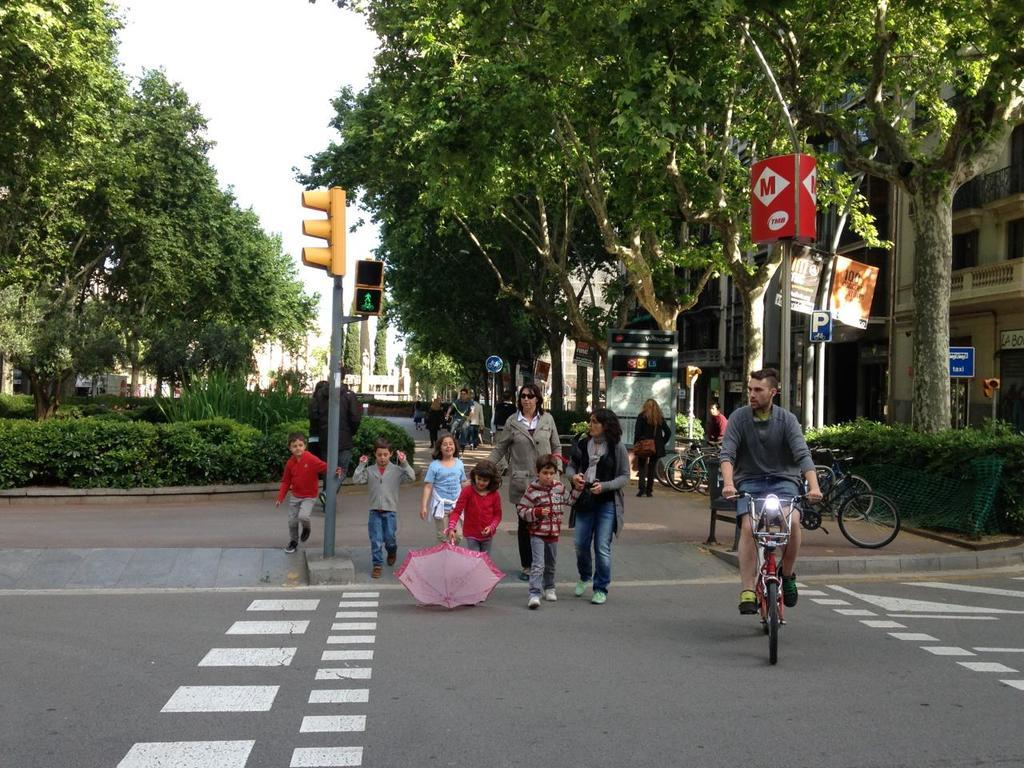<image>
Give a short and clear explanation of the subsequent image. A group of pedestrians are walking across a street under a red sign with an M on it. 